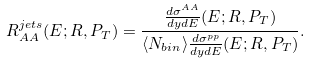<formula> <loc_0><loc_0><loc_500><loc_500>R _ { A A } ^ { j e t s } ( E ; R , P _ { T } ) = \frac { \frac { d \sigma ^ { A A } } { d y d E } ( E ; R , P _ { T } ) } { \langle N _ { b i n } \rangle \frac { d \sigma ^ { p p } } { d y d E } ( E ; R , P _ { T } ) } .</formula> 